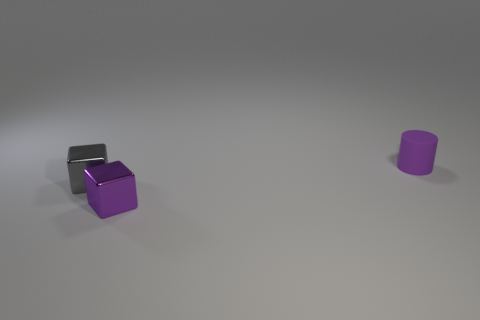Are there more large green objects than purple rubber objects?
Your response must be concise. No. What is the material of the tiny purple cylinder?
Your answer should be very brief. Rubber. The other thing that is the same shape as the small purple metallic object is what size?
Make the answer very short. Small. Are there any tiny gray shiny cubes to the right of the tiny purple object right of the small purple metal thing?
Give a very brief answer. No. What number of other things are the same shape as the tiny purple rubber thing?
Your answer should be compact. 0. Is the number of tiny purple metallic things that are in front of the cylinder greater than the number of purple cubes to the left of the purple metallic thing?
Your answer should be very brief. Yes. There is a shiny block right of the small gray metal block; is its size the same as the purple object behind the small gray thing?
Your response must be concise. Yes. What is the shape of the tiny purple metallic thing?
Your answer should be compact. Cube. What size is the thing that is the same color as the small rubber cylinder?
Keep it short and to the point. Small. There is another tiny block that is the same material as the gray cube; what is its color?
Give a very brief answer. Purple. 